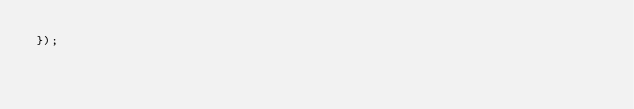Convert code to text. <code><loc_0><loc_0><loc_500><loc_500><_JavaScript_>});</code> 